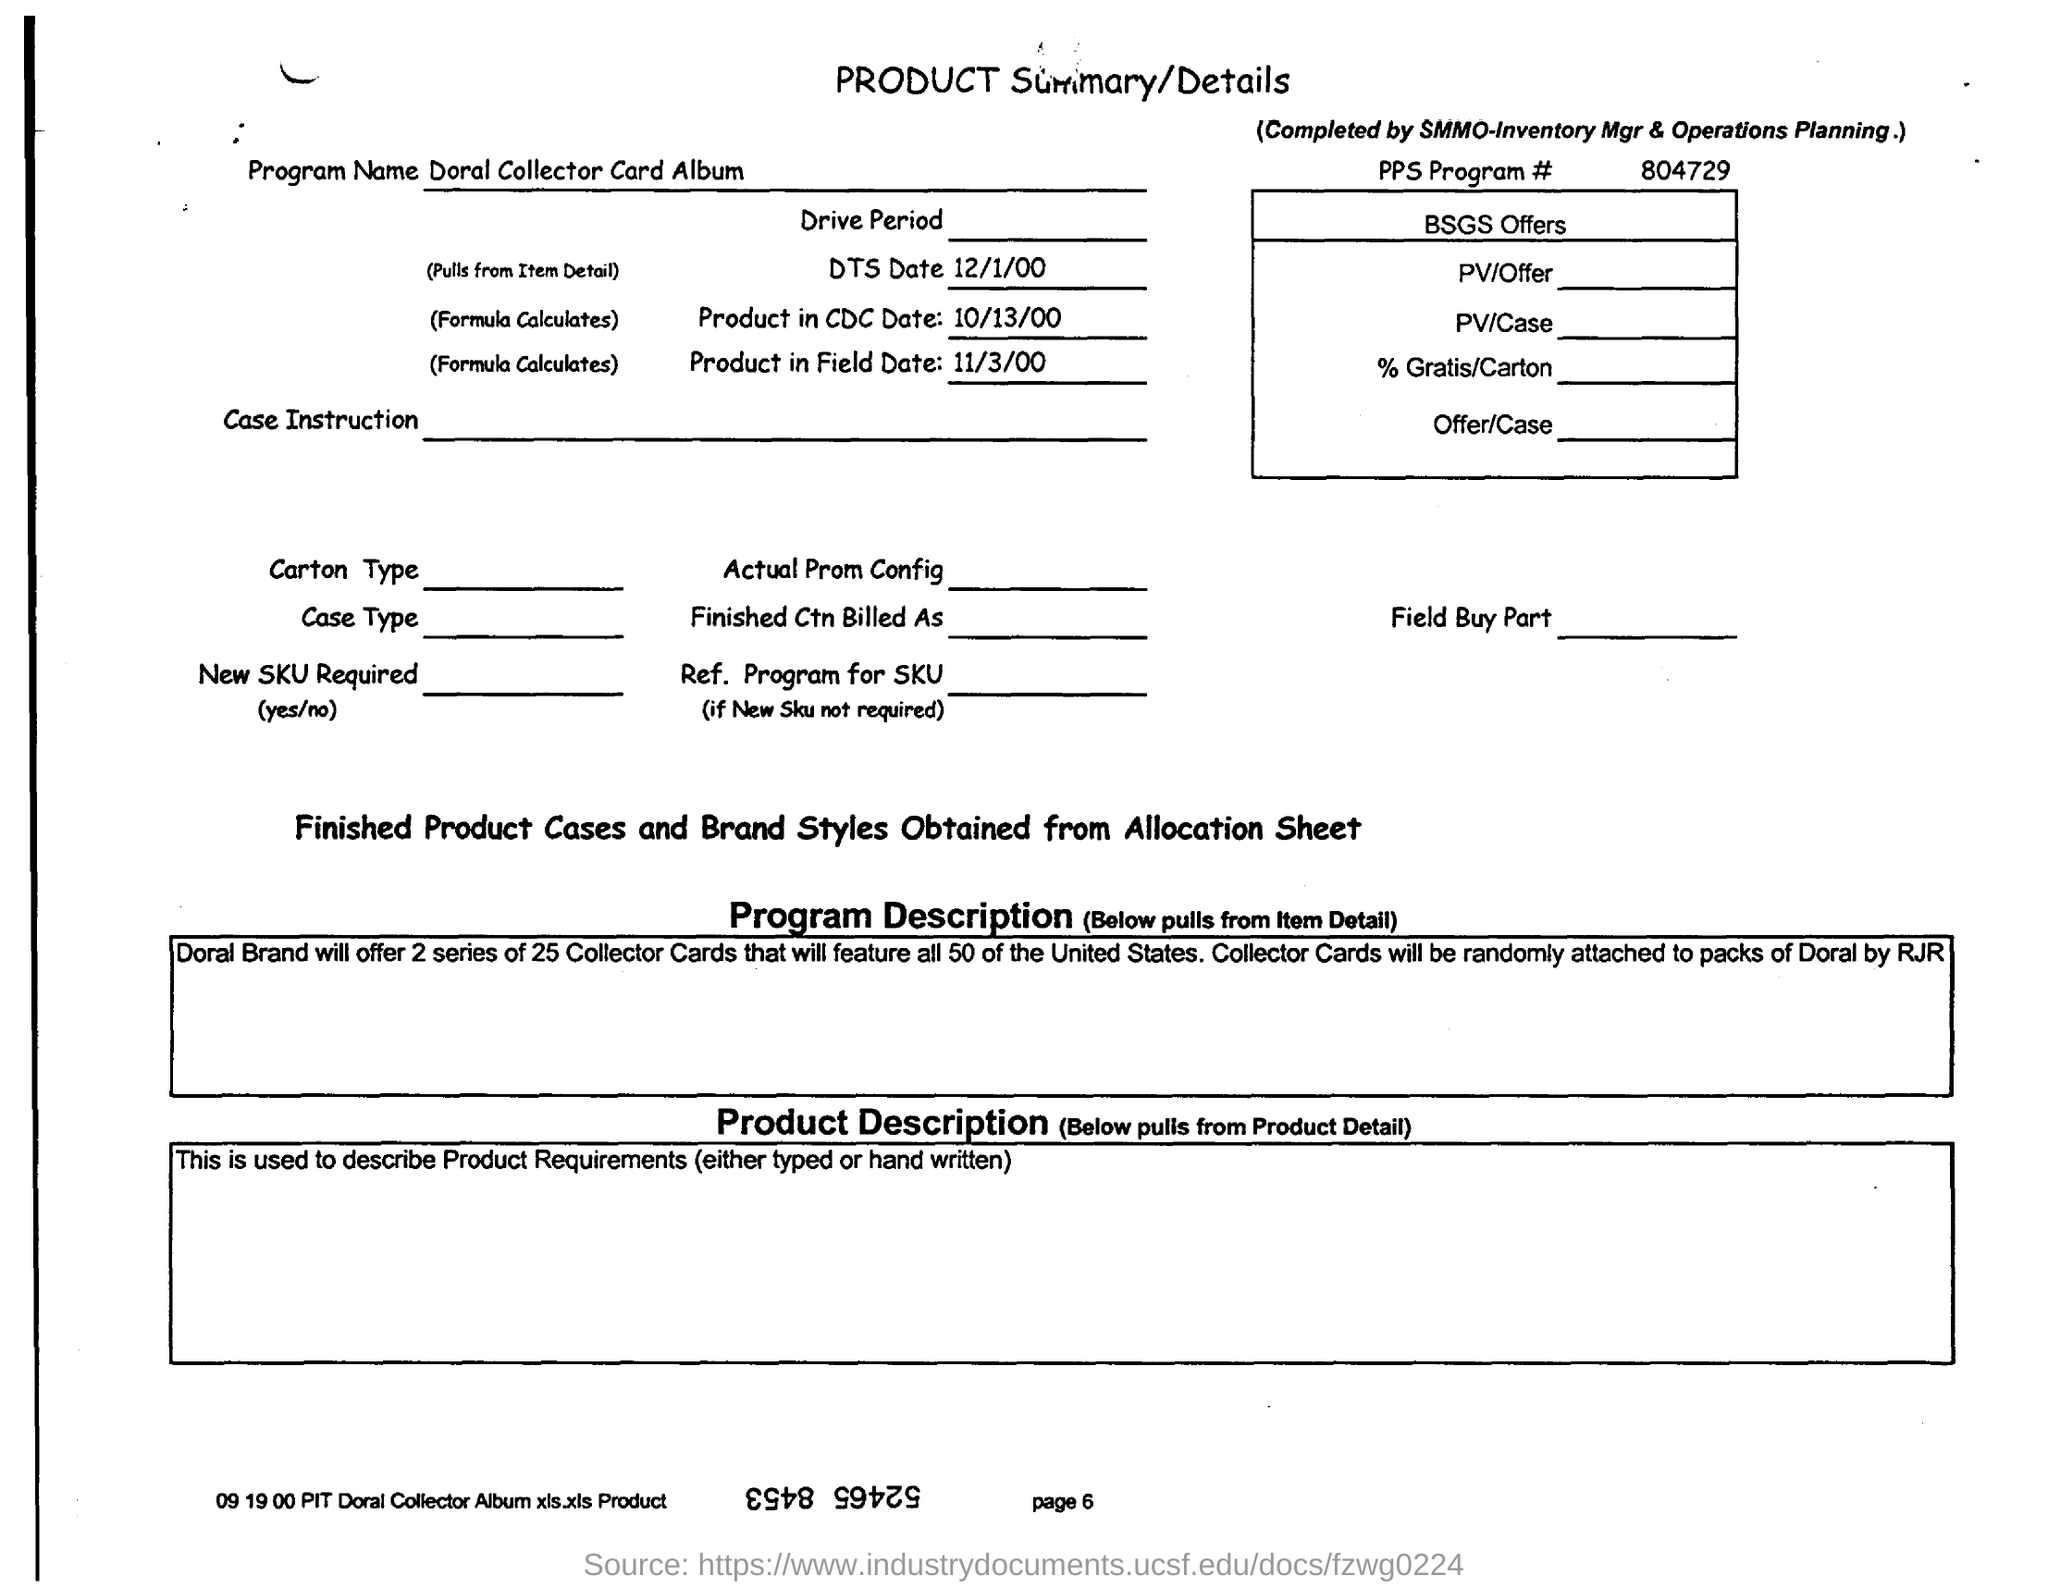Point out several critical features in this image. The DTS date mentioned in the product summary is December 1, 2000. The PPS program number given in the product summary/details is 804729. The product summary/details provides the name of the program as Doral Collector Card Album. 